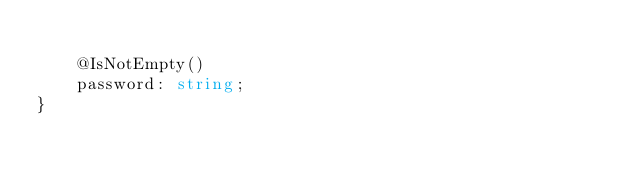<code> <loc_0><loc_0><loc_500><loc_500><_TypeScript_>
    @IsNotEmpty()
    password: string;
}
</code> 